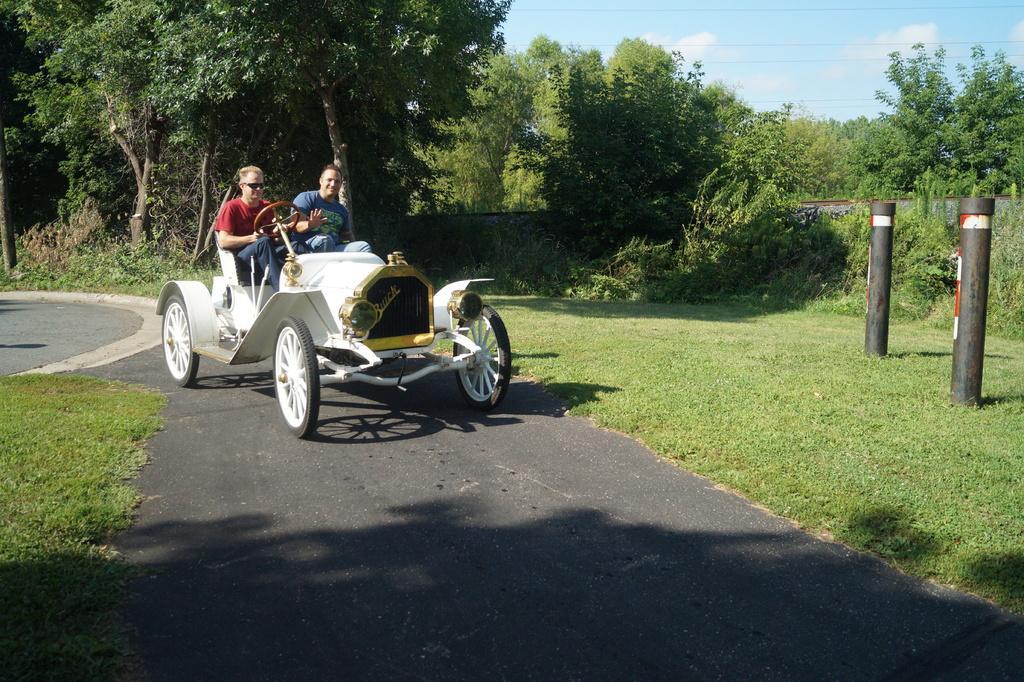Could you give a brief overview of what you see in this image? In this picture there is a woman who is wearing goggles, red t-shirt and jeans. Beside there is a man who is wearing blue t-shirt and jeans. Both of them are sitting on the car's seat and she is riding a car on the road. On the right there are two black holes, beside that I can see the plants and grass. In the background I can see many trees and wall. In the top right I can see the sky and clouds. 